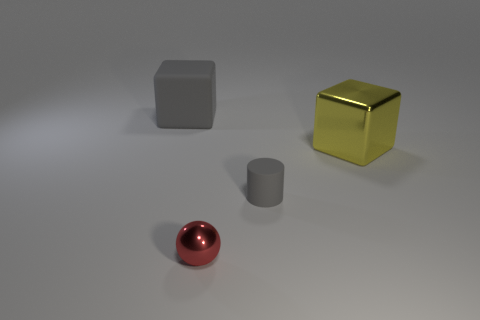Add 2 tiny gray matte balls. How many objects exist? 6 Subtract all spheres. How many objects are left? 3 Add 4 small metal balls. How many small metal balls exist? 5 Subtract 0 blue spheres. How many objects are left? 4 Subtract all gray cylinders. Subtract all tiny red things. How many objects are left? 2 Add 3 large gray things. How many large gray things are left? 4 